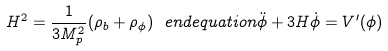<formula> <loc_0><loc_0><loc_500><loc_500>H ^ { 2 } = \frac { 1 } { 3 M _ { p } ^ { 2 } } ( \rho _ { b } + \rho _ { \phi } ) \ e n d { e q u a t i o n } \ddot { \phi } + 3 H \dot { \phi } = V ^ { \prime } ( \phi )</formula> 